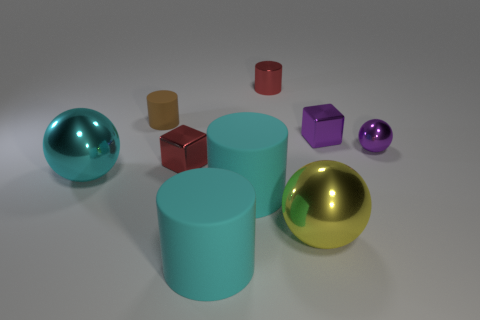What shape is the yellow thing that is made of the same material as the big cyan ball?
Keep it short and to the point. Sphere. There is a tiny brown thing; does it have the same shape as the cyan object that is left of the red cube?
Provide a succinct answer. No. There is a block right of the cyan matte cylinder behind the large yellow shiny object; what is its material?
Give a very brief answer. Metal. What number of other things are there of the same shape as the tiny brown object?
Keep it short and to the point. 3. There is a rubber thing that is behind the cyan metal ball; is it the same shape as the tiny red metallic thing in front of the small purple sphere?
Offer a terse response. No. What is the material of the tiny sphere?
Offer a very short reply. Metal. What is the material of the cube that is left of the yellow shiny thing?
Keep it short and to the point. Metal. Are there any other things of the same color as the tiny matte cylinder?
Keep it short and to the point. No. There is a cyan sphere that is the same material as the tiny red cube; what is its size?
Give a very brief answer. Large. How many large objects are brown cubes or red metal objects?
Your response must be concise. 0. 